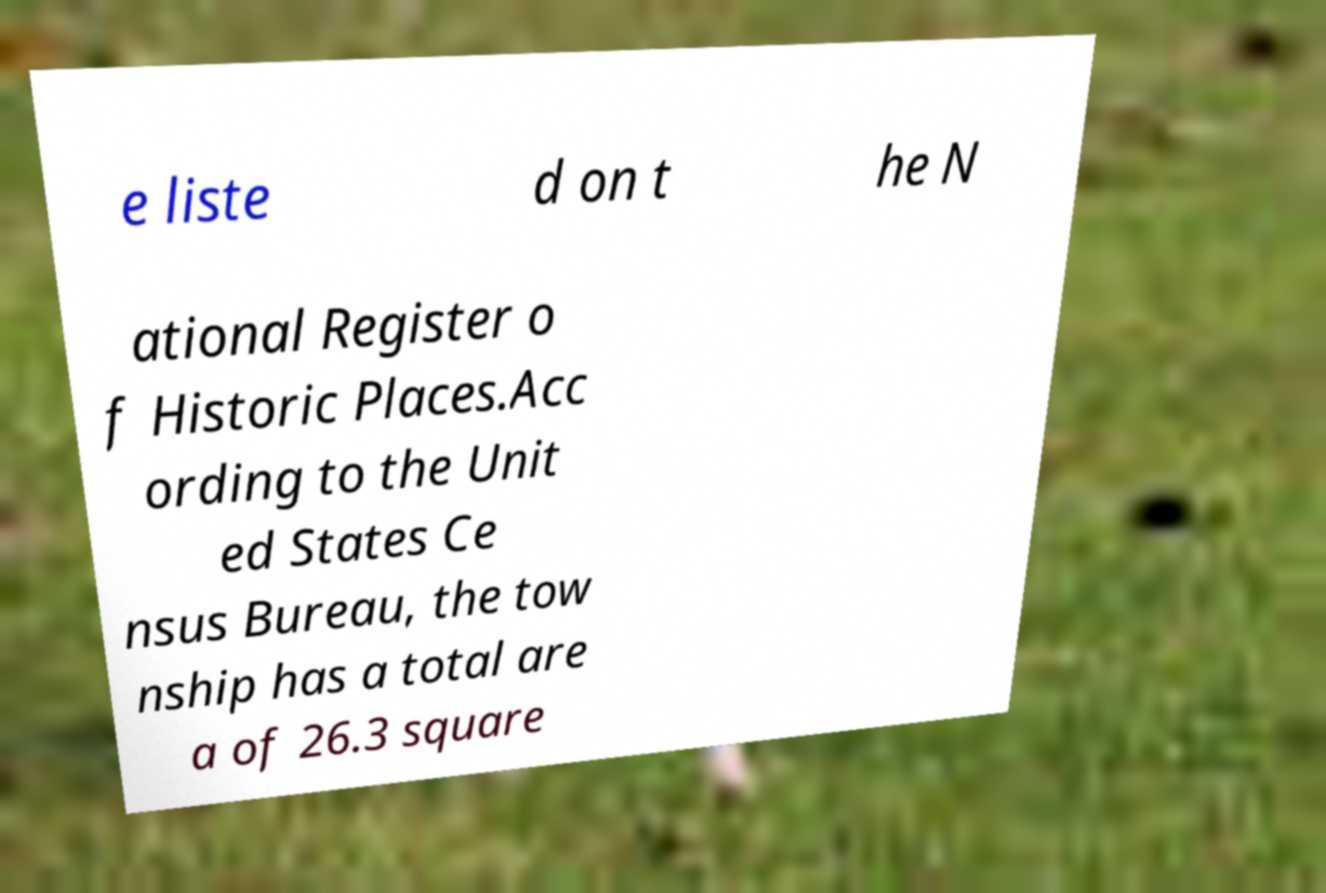There's text embedded in this image that I need extracted. Can you transcribe it verbatim? e liste d on t he N ational Register o f Historic Places.Acc ording to the Unit ed States Ce nsus Bureau, the tow nship has a total are a of 26.3 square 